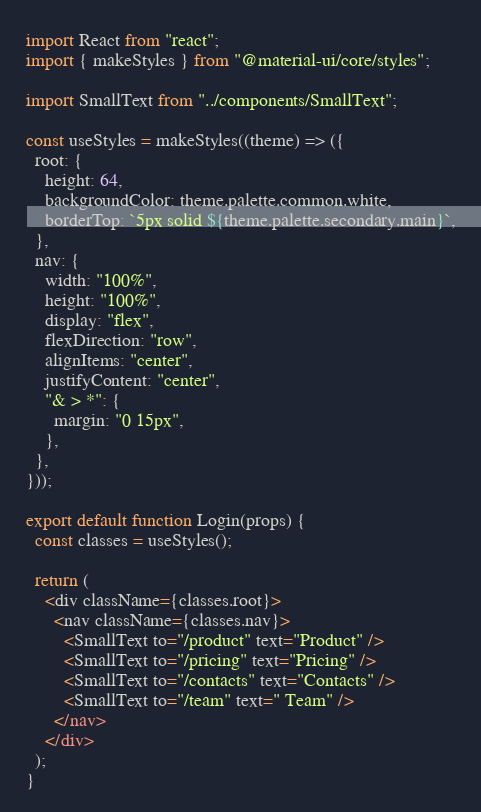Convert code to text. <code><loc_0><loc_0><loc_500><loc_500><_JavaScript_>import React from "react";
import { makeStyles } from "@material-ui/core/styles";

import SmallText from "../components/SmallText";

const useStyles = makeStyles((theme) => ({
  root: {
    height: 64,
    backgroundColor: theme.palette.common.white,
    borderTop: `5px solid ${theme.palette.secondary.main}`,
  },
  nav: {
    width: "100%",
    height: "100%",
    display: "flex",
    flexDirection: "row",
    alignItems: "center",
    justifyContent: "center",
    "& > *": {
      margin: "0 15px",
    },
  },
}));

export default function Login(props) {
  const classes = useStyles();

  return (
    <div className={classes.root}>
      <nav className={classes.nav}>
        <SmallText to="/product" text="Product" />
        <SmallText to="/pricing" text="Pricing" />
        <SmallText to="/contacts" text="Contacts" />
        <SmallText to="/team" text=" Team" />
      </nav>
    </div>
  );
}
</code> 